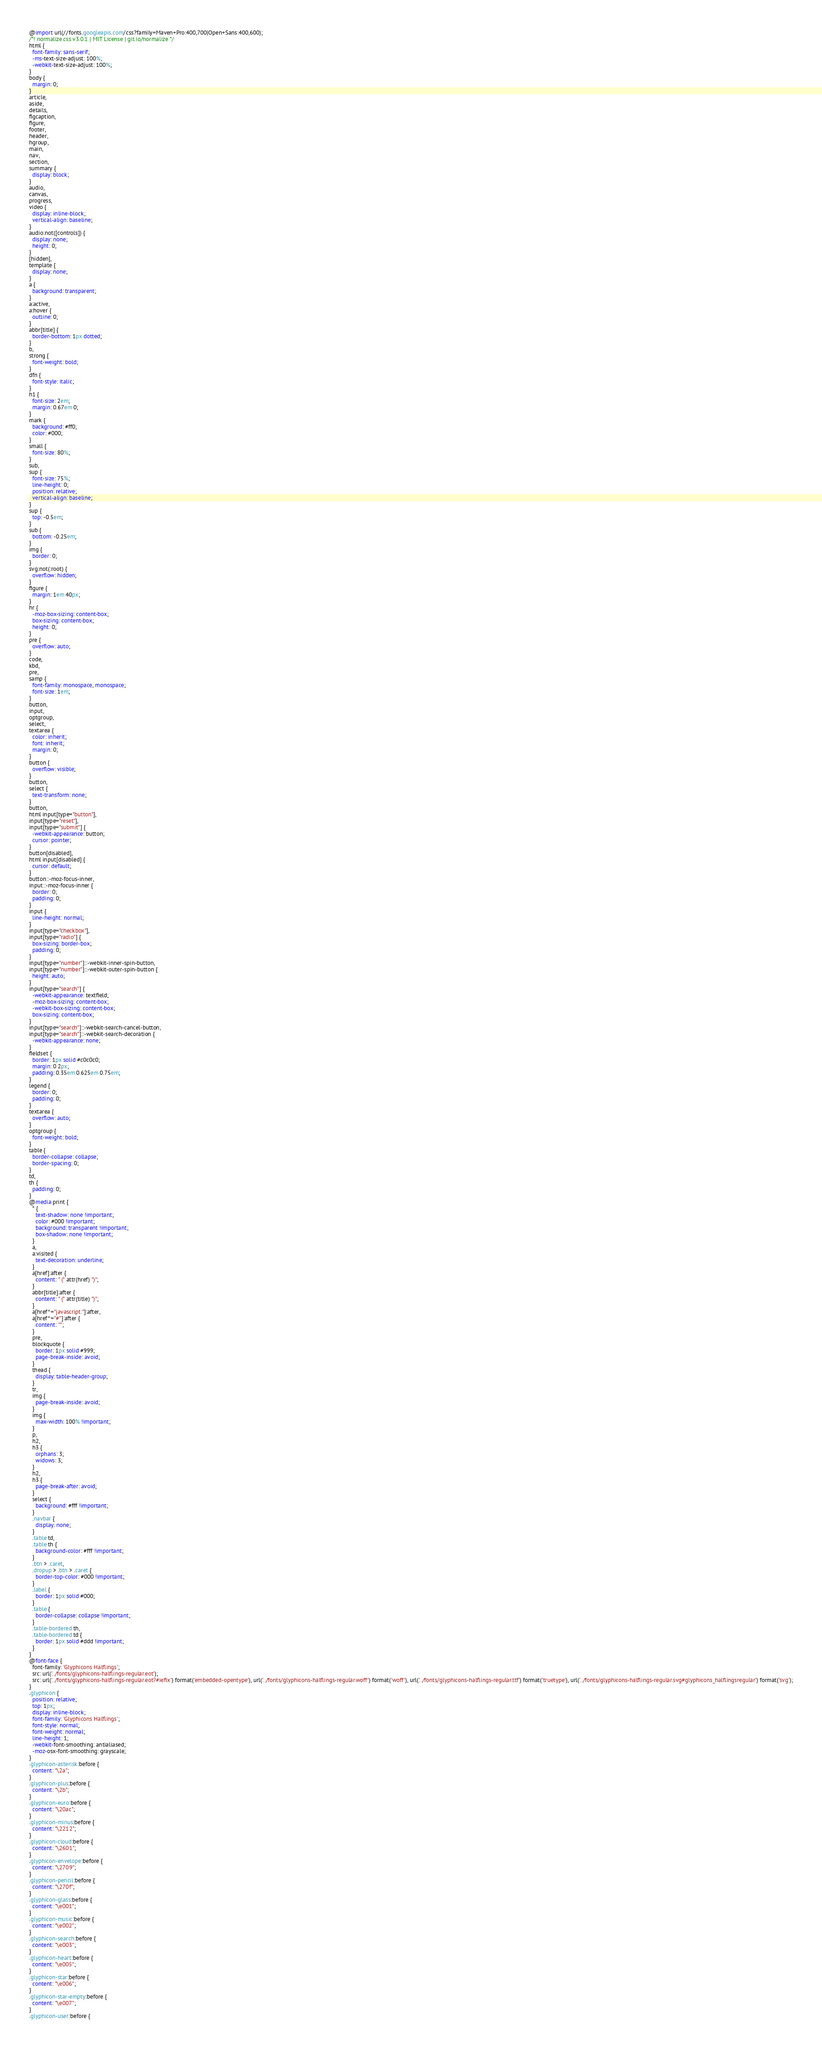<code> <loc_0><loc_0><loc_500><loc_500><_CSS_>@import url(//fonts.googleapis.com/css?family=Maven+Pro:400,700|Open+Sans:400,600);
/*! normalize.css v3.0.1 | MIT License | git.io/normalize */
html {
  font-family: sans-serif;
  -ms-text-size-adjust: 100%;
  -webkit-text-size-adjust: 100%;
}
body {
  margin: 0;
}
article,
aside,
details,
figcaption,
figure,
footer,
header,
hgroup,
main,
nav,
section,
summary {
  display: block;
}
audio,
canvas,
progress,
video {
  display: inline-block;
  vertical-align: baseline;
}
audio:not([controls]) {
  display: none;
  height: 0;
}
[hidden],
template {
  display: none;
}
a {
  background: transparent;
}
a:active,
a:hover {
  outline: 0;
}
abbr[title] {
  border-bottom: 1px dotted;
}
b,
strong {
  font-weight: bold;
}
dfn {
  font-style: italic;
}
h1 {
  font-size: 2em;
  margin: 0.67em 0;
}
mark {
  background: #ff0;
  color: #000;
}
small {
  font-size: 80%;
}
sub,
sup {
  font-size: 75%;
  line-height: 0;
  position: relative;
  vertical-align: baseline;
}
sup {
  top: -0.5em;
}
sub {
  bottom: -0.25em;
}
img {
  border: 0;
}
svg:not(:root) {
  overflow: hidden;
}
figure {
  margin: 1em 40px;
}
hr {
  -moz-box-sizing: content-box;
  box-sizing: content-box;
  height: 0;
}
pre {
  overflow: auto;
}
code,
kbd,
pre,
samp {
  font-family: monospace, monospace;
  font-size: 1em;
}
button,
input,
optgroup,
select,
textarea {
  color: inherit;
  font: inherit;
  margin: 0;
}
button {
  overflow: visible;
}
button,
select {
  text-transform: none;
}
button,
html input[type="button"],
input[type="reset"],
input[type="submit"] {
  -webkit-appearance: button;
  cursor: pointer;
}
button[disabled],
html input[disabled] {
  cursor: default;
}
button::-moz-focus-inner,
input::-moz-focus-inner {
  border: 0;
  padding: 0;
}
input {
  line-height: normal;
}
input[type="checkbox"],
input[type="radio"] {
  box-sizing: border-box;
  padding: 0;
}
input[type="number"]::-webkit-inner-spin-button,
input[type="number"]::-webkit-outer-spin-button {
  height: auto;
}
input[type="search"] {
  -webkit-appearance: textfield;
  -moz-box-sizing: content-box;
  -webkit-box-sizing: content-box;
  box-sizing: content-box;
}
input[type="search"]::-webkit-search-cancel-button,
input[type="search"]::-webkit-search-decoration {
  -webkit-appearance: none;
}
fieldset {
  border: 1px solid #c0c0c0;
  margin: 0 2px;
  padding: 0.35em 0.625em 0.75em;
}
legend {
  border: 0;
  padding: 0;
}
textarea {
  overflow: auto;
}
optgroup {
  font-weight: bold;
}
table {
  border-collapse: collapse;
  border-spacing: 0;
}
td,
th {
  padding: 0;
}
@media print {
  * {
    text-shadow: none !important;
    color: #000 !important;
    background: transparent !important;
    box-shadow: none !important;
  }
  a,
  a:visited {
    text-decoration: underline;
  }
  a[href]:after {
    content: " (" attr(href) ")";
  }
  abbr[title]:after {
    content: " (" attr(title) ")";
  }
  a[href^="javascript:"]:after,
  a[href^="#"]:after {
    content: "";
  }
  pre,
  blockquote {
    border: 1px solid #999;
    page-break-inside: avoid;
  }
  thead {
    display: table-header-group;
  }
  tr,
  img {
    page-break-inside: avoid;
  }
  img {
    max-width: 100% !important;
  }
  p,
  h2,
  h3 {
    orphans: 3;
    widows: 3;
  }
  h2,
  h3 {
    page-break-after: avoid;
  }
  select {
    background: #fff !important;
  }
  .navbar {
    display: none;
  }
  .table td,
  .table th {
    background-color: #fff !important;
  }
  .btn > .caret,
  .dropup > .btn > .caret {
    border-top-color: #000 !important;
  }
  .label {
    border: 1px solid #000;
  }
  .table {
    border-collapse: collapse !important;
  }
  .table-bordered th,
  .table-bordered td {
    border: 1px solid #ddd !important;
  }
}
@font-face {
  font-family: 'Glyphicons Halflings';
  src: url('../fonts/glyphicons-halflings-regular.eot');
  src: url('../fonts/glyphicons-halflings-regular.eot?#iefix') format('embedded-opentype'), url('../fonts/glyphicons-halflings-regular.woff') format('woff'), url('../fonts/glyphicons-halflings-regular.ttf') format('truetype'), url('../fonts/glyphicons-halflings-regular.svg#glyphicons_halflingsregular') format('svg');
}
.glyphicon {
  position: relative;
  top: 1px;
  display: inline-block;
  font-family: 'Glyphicons Halflings';
  font-style: normal;
  font-weight: normal;
  line-height: 1;
  -webkit-font-smoothing: antialiased;
  -moz-osx-font-smoothing: grayscale;
}
.glyphicon-asterisk:before {
  content: "\2a";
}
.glyphicon-plus:before {
  content: "\2b";
}
.glyphicon-euro:before {
  content: "\20ac";
}
.glyphicon-minus:before {
  content: "\2212";
}
.glyphicon-cloud:before {
  content: "\2601";
}
.glyphicon-envelope:before {
  content: "\2709";
}
.glyphicon-pencil:before {
  content: "\270f";
}
.glyphicon-glass:before {
  content: "\e001";
}
.glyphicon-music:before {
  content: "\e002";
}
.glyphicon-search:before {
  content: "\e003";
}
.glyphicon-heart:before {
  content: "\e005";
}
.glyphicon-star:before {
  content: "\e006";
}
.glyphicon-star-empty:before {
  content: "\e007";
}
.glyphicon-user:before {</code> 